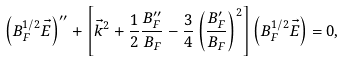<formula> <loc_0><loc_0><loc_500><loc_500>\left ( B _ { F } ^ { 1 / 2 } \vec { E } \right ) ^ { \prime \prime } + \left [ \vec { k } ^ { 2 } + \frac { 1 } { 2 } \frac { B _ { F } ^ { \prime \prime } } { B _ { F } } - \frac { 3 } { 4 } \left ( \frac { B _ { F } ^ { \prime } } { B _ { F } } \right ) ^ { 2 } \right ] \left ( B _ { F } ^ { 1 / 2 } \vec { E } \right ) = 0 ,</formula> 